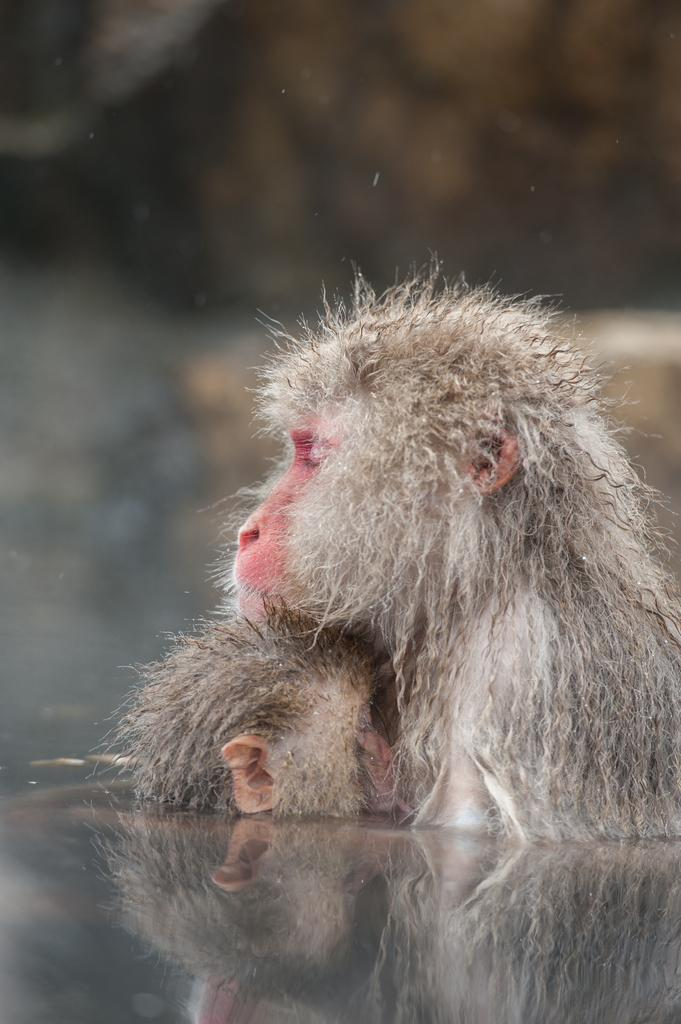How many monkeys are present in the image? There are two monkeys in the image. What color are the monkeys? The monkeys are grey in color. What type of grain is being fed to the monkeys in the image? There is no grain present in the image, as it only features two grey monkeys. 